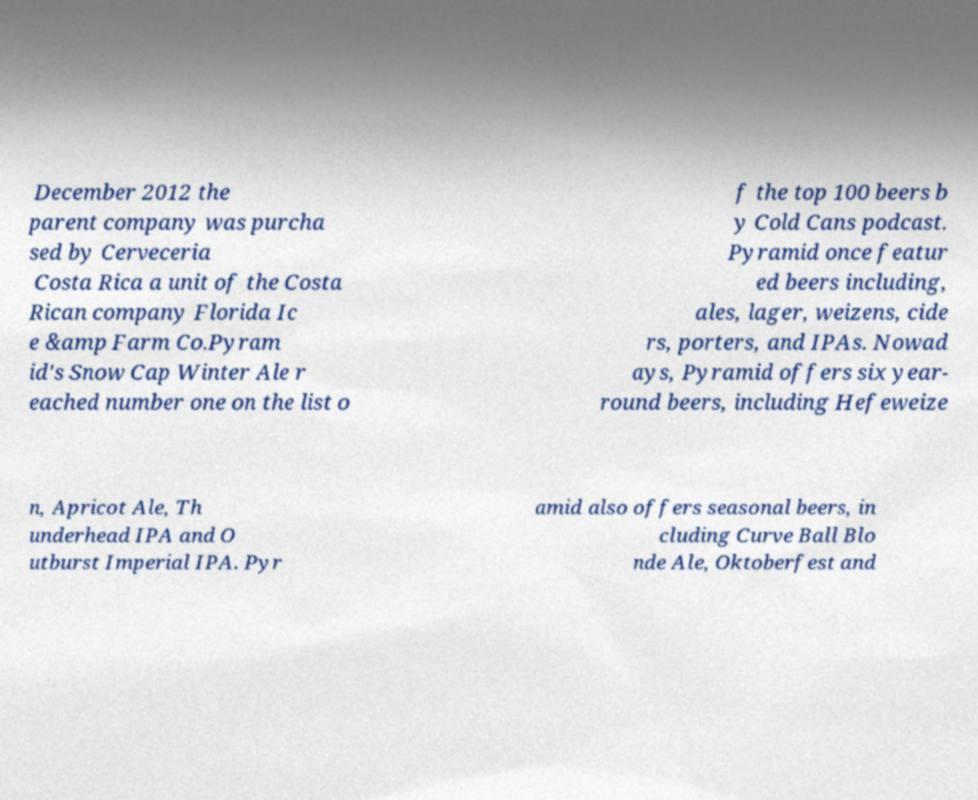Could you assist in decoding the text presented in this image and type it out clearly? December 2012 the parent company was purcha sed by Cerveceria Costa Rica a unit of the Costa Rican company Florida Ic e &amp Farm Co.Pyram id's Snow Cap Winter Ale r eached number one on the list o f the top 100 beers b y Cold Cans podcast. Pyramid once featur ed beers including, ales, lager, weizens, cide rs, porters, and IPAs. Nowad ays, Pyramid offers six year- round beers, including Hefeweize n, Apricot Ale, Th underhead IPA and O utburst Imperial IPA. Pyr amid also offers seasonal beers, in cluding Curve Ball Blo nde Ale, Oktoberfest and 